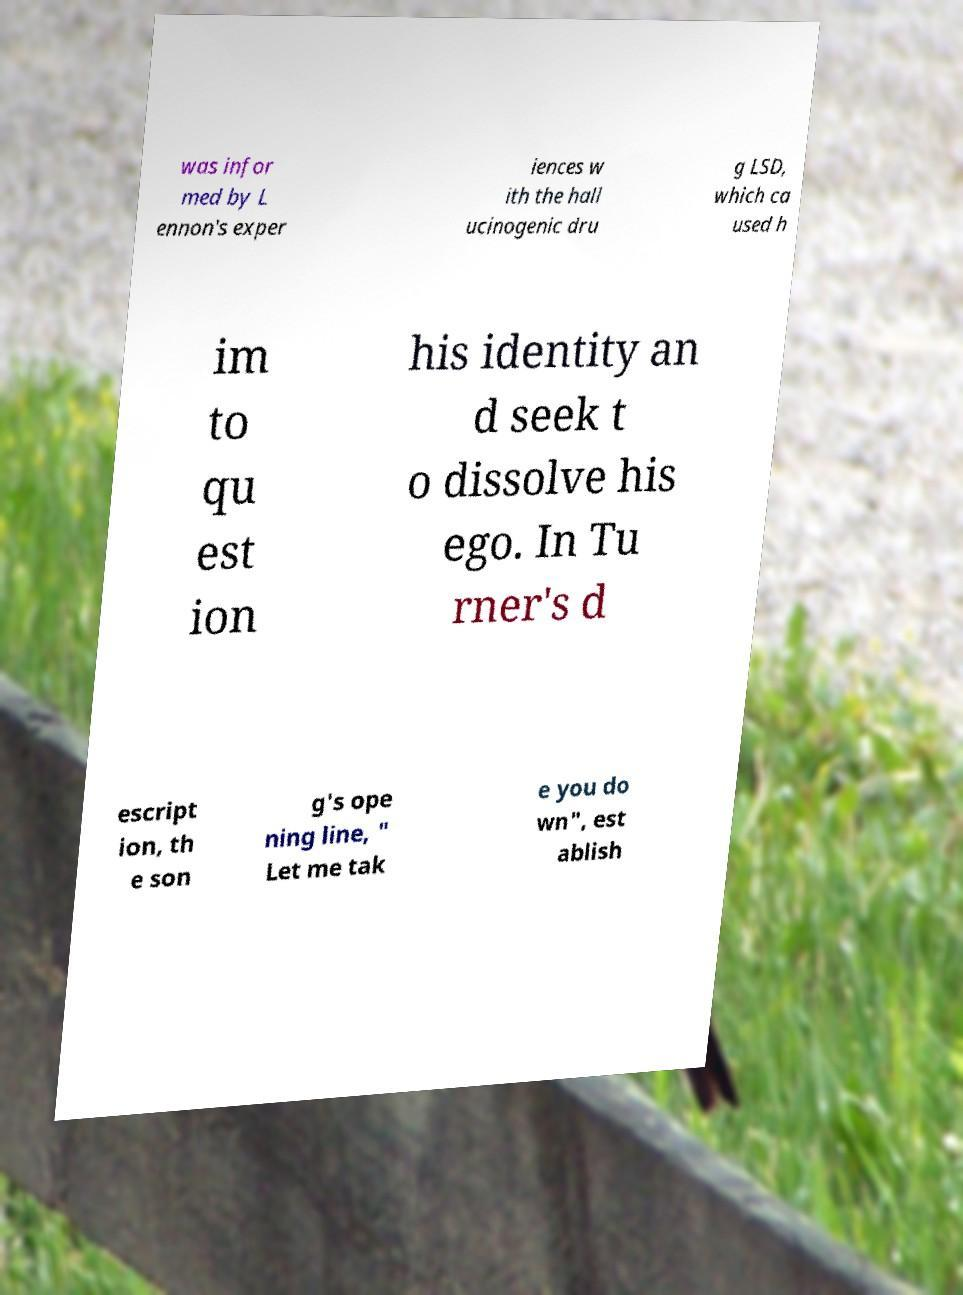For documentation purposes, I need the text within this image transcribed. Could you provide that? was infor med by L ennon's exper iences w ith the hall ucinogenic dru g LSD, which ca used h im to qu est ion his identity an d seek t o dissolve his ego. In Tu rner's d escript ion, th e son g's ope ning line, " Let me tak e you do wn", est ablish 